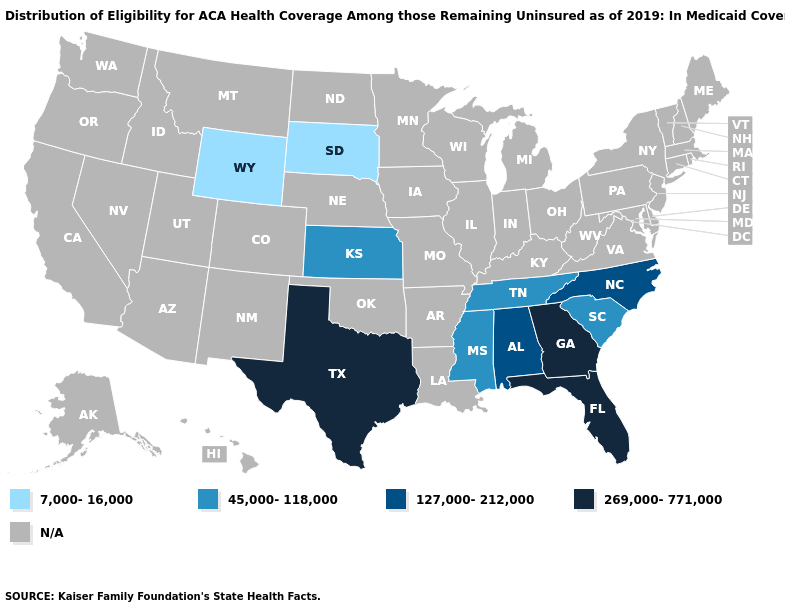What is the value of Arkansas?
Be succinct. N/A. Name the states that have a value in the range 45,000-118,000?
Concise answer only. Kansas, Mississippi, South Carolina, Tennessee. Name the states that have a value in the range 45,000-118,000?
Write a very short answer. Kansas, Mississippi, South Carolina, Tennessee. What is the highest value in the USA?
Keep it brief. 269,000-771,000. Does Georgia have the highest value in the South?
Write a very short answer. Yes. What is the value of Vermont?
Quick response, please. N/A. Name the states that have a value in the range 45,000-118,000?
Quick response, please. Kansas, Mississippi, South Carolina, Tennessee. What is the value of Alaska?
Give a very brief answer. N/A. What is the value of Washington?
Write a very short answer. N/A. Among the states that border Iowa , which have the lowest value?
Quick response, please. South Dakota. Name the states that have a value in the range N/A?
Be succinct. Alaska, Arizona, Arkansas, California, Colorado, Connecticut, Delaware, Hawaii, Idaho, Illinois, Indiana, Iowa, Kentucky, Louisiana, Maine, Maryland, Massachusetts, Michigan, Minnesota, Missouri, Montana, Nebraska, Nevada, New Hampshire, New Jersey, New Mexico, New York, North Dakota, Ohio, Oklahoma, Oregon, Pennsylvania, Rhode Island, Utah, Vermont, Virginia, Washington, West Virginia, Wisconsin. What is the value of Utah?
Be succinct. N/A. What is the value of Kentucky?
Short answer required. N/A. Name the states that have a value in the range 45,000-118,000?
Concise answer only. Kansas, Mississippi, South Carolina, Tennessee. 